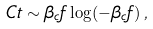<formula> <loc_0><loc_0><loc_500><loc_500>C t \sim \beta _ { c } f \log ( - \beta _ { c } f ) \, ,</formula> 